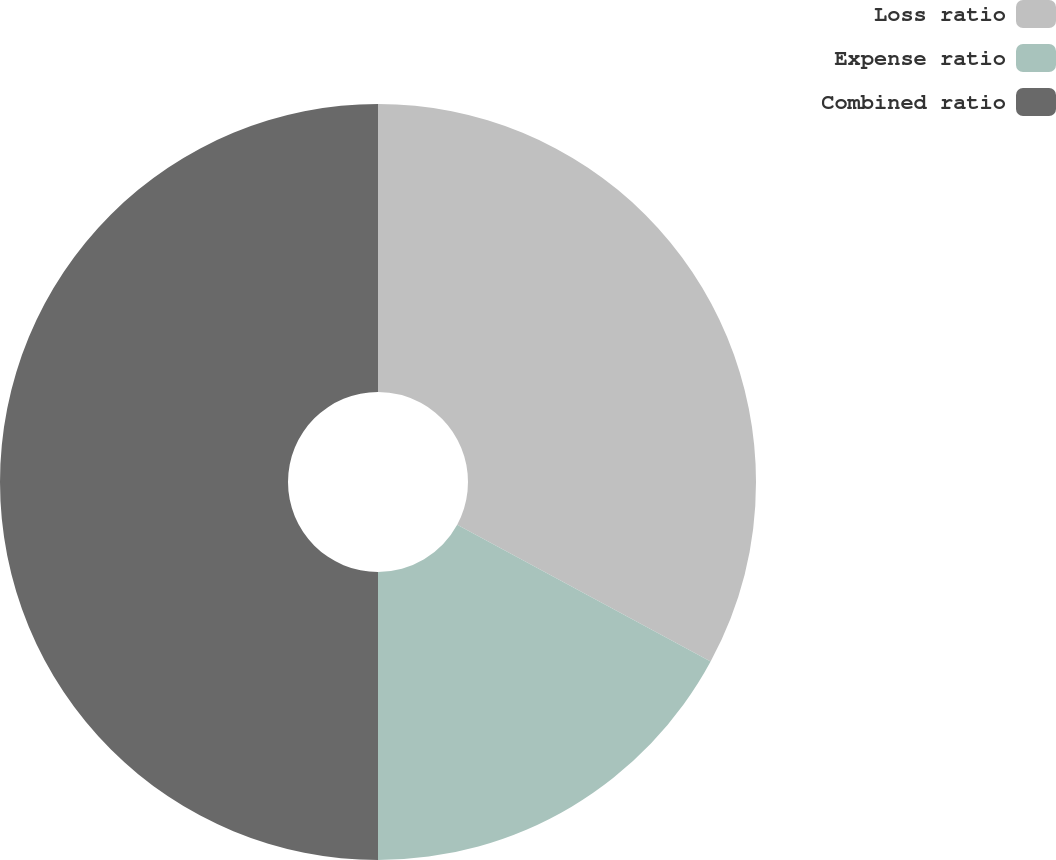Convert chart to OTSL. <chart><loc_0><loc_0><loc_500><loc_500><pie_chart><fcel>Loss ratio<fcel>Expense ratio<fcel>Combined ratio<nl><fcel>32.88%<fcel>17.12%<fcel>50.0%<nl></chart> 